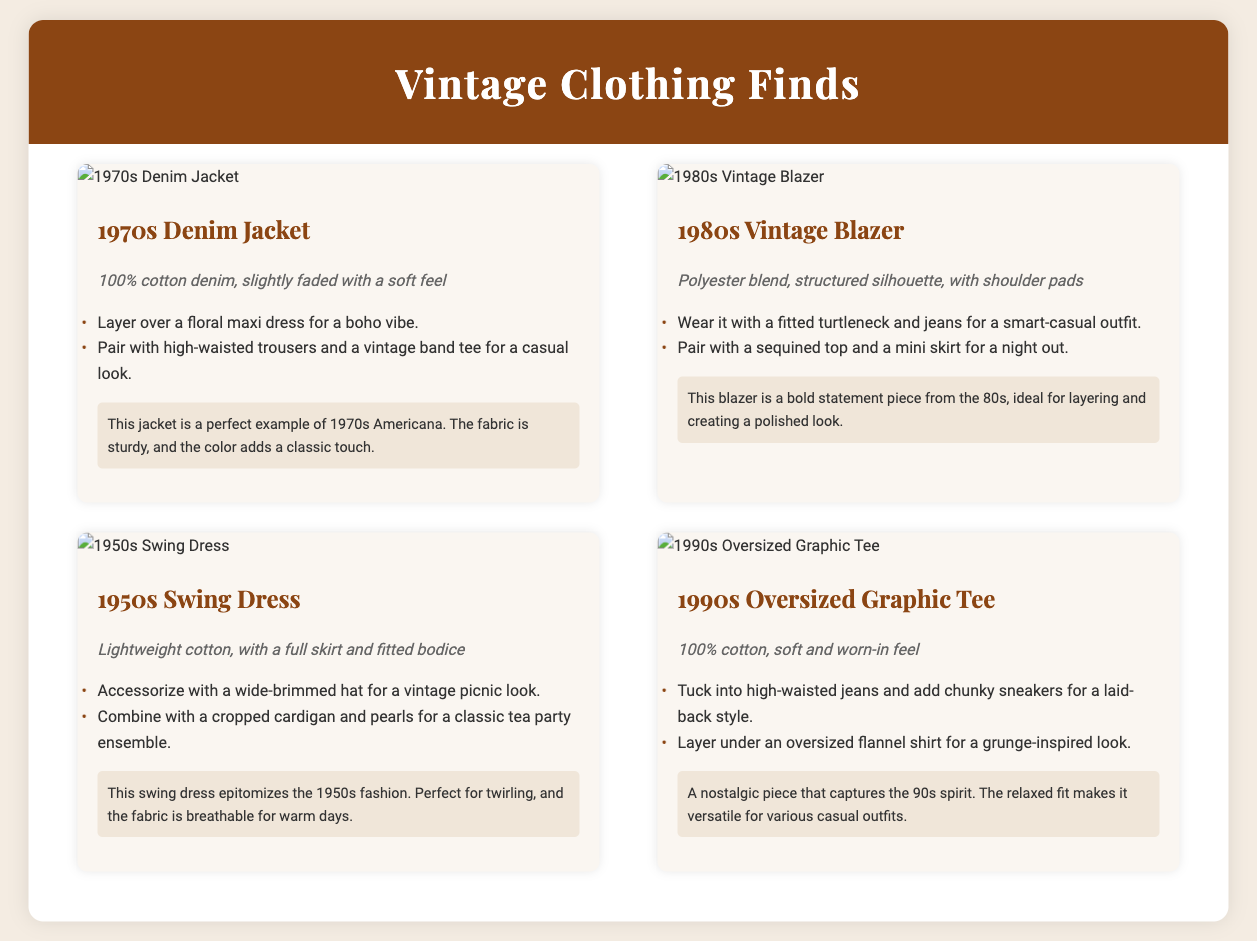What decade is the denim jacket from? The denim jacket is identified as being from the 1970s in the catalog.
Answer: 1970s What fabric is the 1980s vintage blazer made of? The 1980s vintage blazer is made from a polyester blend according to the fabric details provided.
Answer: Polyester blend What styling option is suggested for the 1950s swing dress? One styling option for the 1950s swing dress is to accessorize with a wide-brimmed hat for a vintage picnic look.
Answer: Wide-brimmed hat How many total items are featured in the catalog? The catalog features a total of four unique garments.
Answer: Four What type of dress is the 1950s item? The 1950s item is specified as a swing dress in the document.
Answer: Swing dress Which vintage item is described as having a "soft and worn-in feel"? The item that is described as having a "soft and worn-in feel" is the 1990s oversized graphic tee.
Answer: 1990s oversized graphic tee What is the main color associated with the header? The main color associated with the header of the catalog is a brownish color, specifically stated as #8b4513 in the design.
Answer: #8b4513 What is a common feature of all items in the catalog? A common feature of all items in the catalog is that they are all vintage clothing finds from different decades.
Answer: Vintage clothing finds 